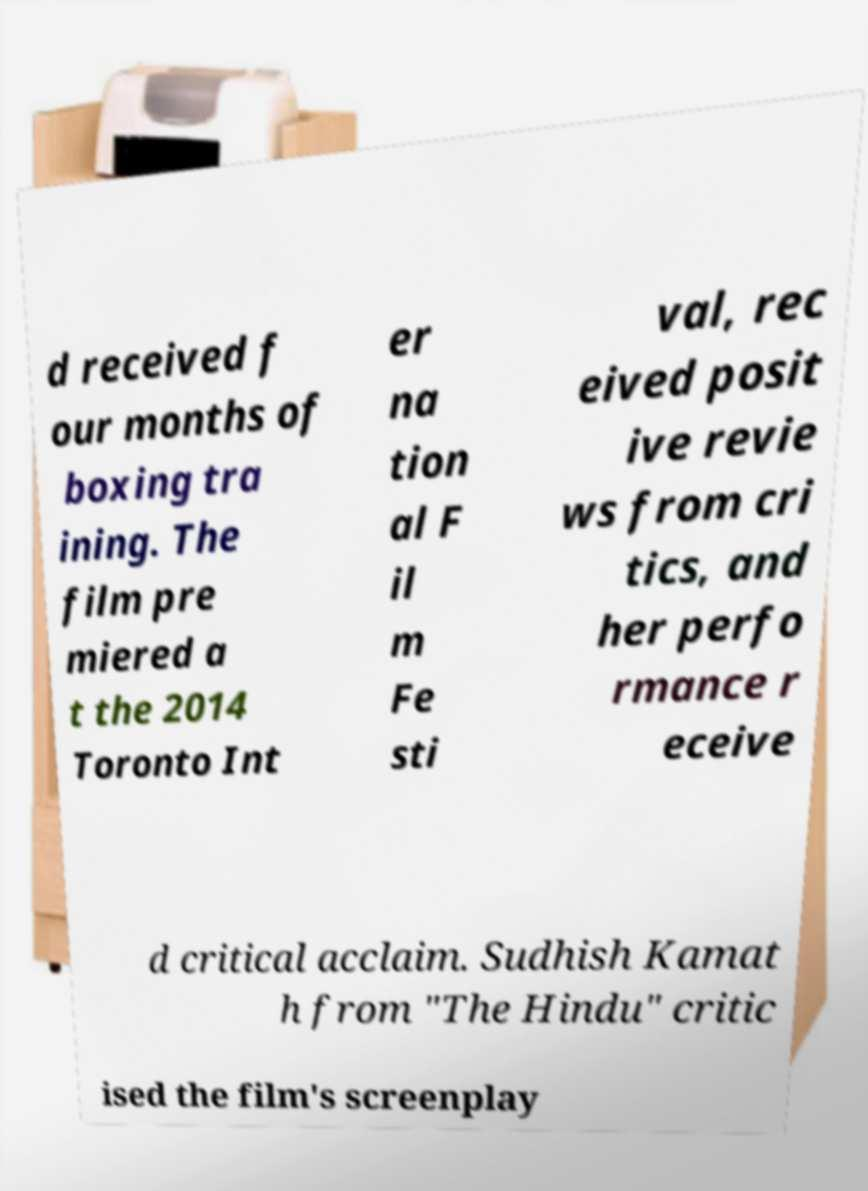Could you extract and type out the text from this image? d received f our months of boxing tra ining. The film pre miered a t the 2014 Toronto Int er na tion al F il m Fe sti val, rec eived posit ive revie ws from cri tics, and her perfo rmance r eceive d critical acclaim. Sudhish Kamat h from "The Hindu" critic ised the film's screenplay 